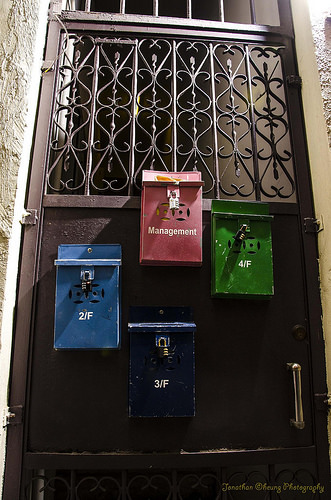<image>
Is the red box behind the blue box? No. The red box is not behind the blue box. From this viewpoint, the red box appears to be positioned elsewhere in the scene. 